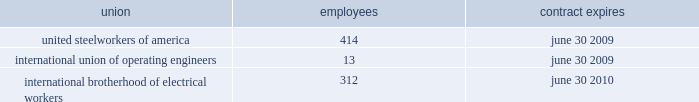Pollutants discharged to waters of the united states and remediation of waters affected by such discharge .
To our knowledge , we are in compliance with all material requirements associated with the various regulations .
The united states congress is actively considering legislation to reduce emissions of greenhouse gases , including carbon dioxide and methane .
In addition , state and regional initiatives to regulate greenhouse gas emissions are underway .
We are monitoring federal and state legislation to assess the potential impact on our operations .
Our most recent calculation of direct greenhouse gas emissions for oneok and oneok partners is estimated to be less than 6 million metric tons of carbon dioxide equivalents on an annual basis .
We will continue efforts to quantify our direct greenhouse gas emissions and will report such emissions as required by any mandatory reporting rule , including the rules anticipated to be issued by the epa in mid-2009 .
Superfund - the comprehensive environmental response , compensation and liability act , also known as cercla or superfund , imposes liability , without regard to fault or the legality of the original act , on certain classes of persons who contributed to the release of a hazardous substance into the environment .
These persons include the owner or operator of a facility where the release occurred and companies that disposed or arranged for the disposal of the hazardous substances found at the facility .
Under cercla , these persons may be liable for the costs of cleaning up the hazardous substances released into the environment , damages to natural resources and the costs of certain health studies .
Chemical site security - the united states department of homeland security ( homeland security ) released an interim rule in april 2007 that requires companies to provide reports on sites where certain chemicals , including many hydrocarbon products , are stored .
We completed the homeland security assessments and our facilities were subsequently assigned to one of four risk-based tiers ranging from high ( tier 1 ) to low ( tier 4 ) risk , or not tiered at all due to low risk .
A majority of our facilities were not tiered .
We are waiting for homeland security 2019s analysis to determine if any of the tiered facilities will require site security plans and possible physical security enhancements .
Climate change - our environmental and climate change strategy focuses on taking steps to minimize the impact of our operations on the environment .
These strategies include : ( i ) developing and maintaining an accurate greenhouse gas emissions inventory , according to rules anticipated to be issued by the epa in mid-2009 ; ( ii ) improving the efficiency of our various pipelines , natural gas processing facilities and natural gas liquids fractionation facilities ; ( iii ) following developing technologies for emission control ; ( iv ) following developing technologies to capture carbon dioxide to keep it from reaching the atmosphere ; and ( v ) analyzing options for future energy investment .
Currently , certain subsidiaries of oneok partners participate in the processing and transmission sectors and ldcs in our distribution segment participate in the distribution sector of the epa 2019s natural gas star program to voluntarily reduce methane emissions .
A subsidiary in our oneok partners 2019 segment was honored in 2008 as the 201cnatural gas star gathering and processing partner of the year 201d for its efforts to positively address environmental issues through voluntary implementation of emission-reduction opportunities .
In addition , we continue to focus on maintaining low rates of lost-and- unaccounted-for methane gas through expanded implementation of best practices to limit the release of methane during pipeline and facility maintenance and operations .
Our most recent calculation of our annual lost-and-unaccounted-for natural gas , for all of our business operations , is less than 1 percent of total throughput .
Employees we employed 4742 people at january 31 , 2009 , including 739 people employed by kansas gas service , who were subject to collective bargaining contracts .
The table sets forth our contracts with collective bargaining units at january 31 , employees contract expires .

As of january 31 , 2009 what percentage of employees are members of international brotherhood of electrical workers? 
Computations: (312 / 4742)
Answer: 0.0658. 